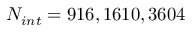Convert formula to latex. <formula><loc_0><loc_0><loc_500><loc_500>N _ { i n t } = 9 1 6 , 1 6 1 0 , 3 6 0 4</formula> 